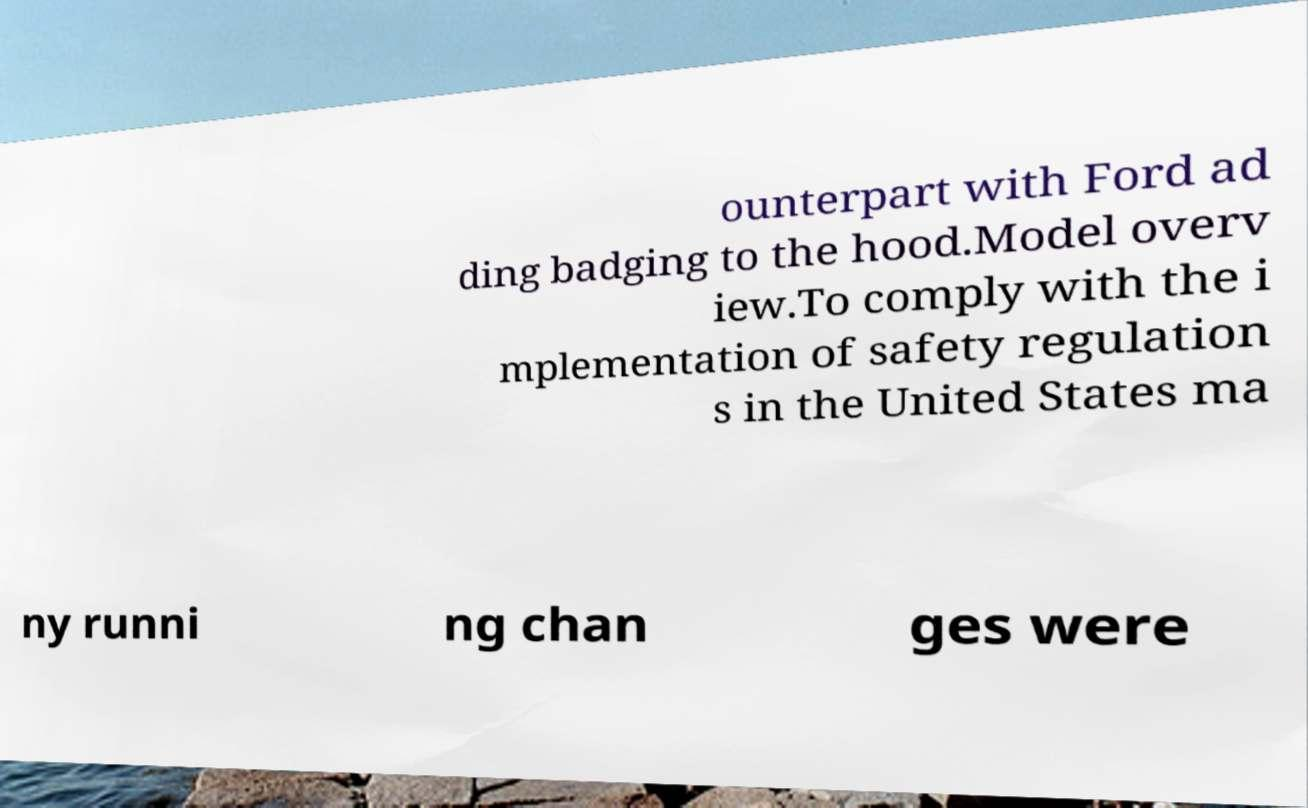Please read and relay the text visible in this image. What does it say? ounterpart with Ford ad ding badging to the hood.Model overv iew.To comply with the i mplementation of safety regulation s in the United States ma ny runni ng chan ges were 